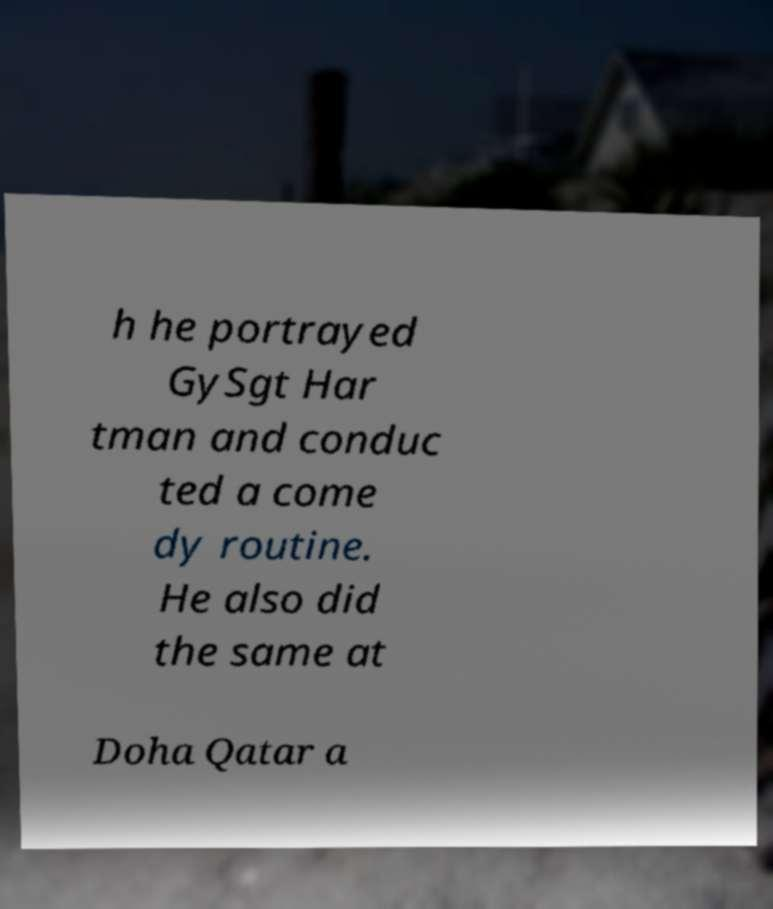There's text embedded in this image that I need extracted. Can you transcribe it verbatim? h he portrayed GySgt Har tman and conduc ted a come dy routine. He also did the same at Doha Qatar a 